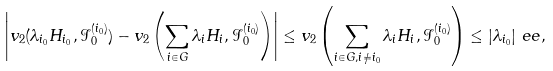Convert formula to latex. <formula><loc_0><loc_0><loc_500><loc_500>\left | v _ { 2 } ( \lambda _ { i _ { 0 } } H _ { i _ { 0 } } , \mathcal { I } _ { 0 } ^ { ( i _ { 0 } ) } ) - v _ { 2 } \left ( \sum _ { i \in G } \lambda _ { i } H _ { i } , \mathcal { I } _ { 0 } ^ { ( i _ { 0 } ) } \right ) \right | & \leq v _ { 2 } \left ( \sum _ { i \in G , i \neq i _ { 0 } } \lambda _ { i } H _ { i } , \mathcal { I } _ { 0 } ^ { ( i _ { 0 } ) } \right ) \leq | \lambda _ { i _ { 0 } } | \ e e ,</formula> 